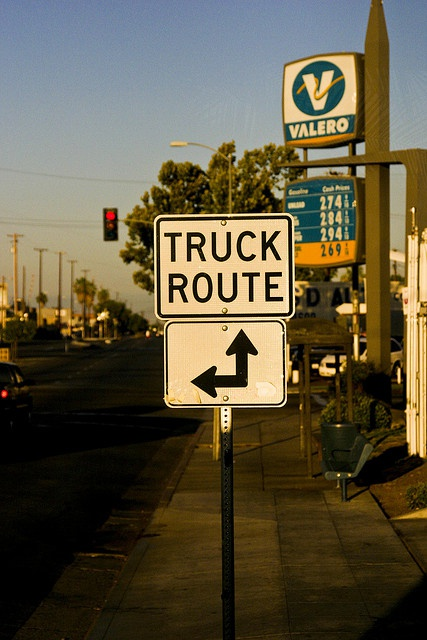Describe the objects in this image and their specific colors. I can see bench in gray, black, and darkgreen tones, car in gray, black, maroon, olive, and red tones, and traffic light in gray, black, maroon, red, and olive tones in this image. 